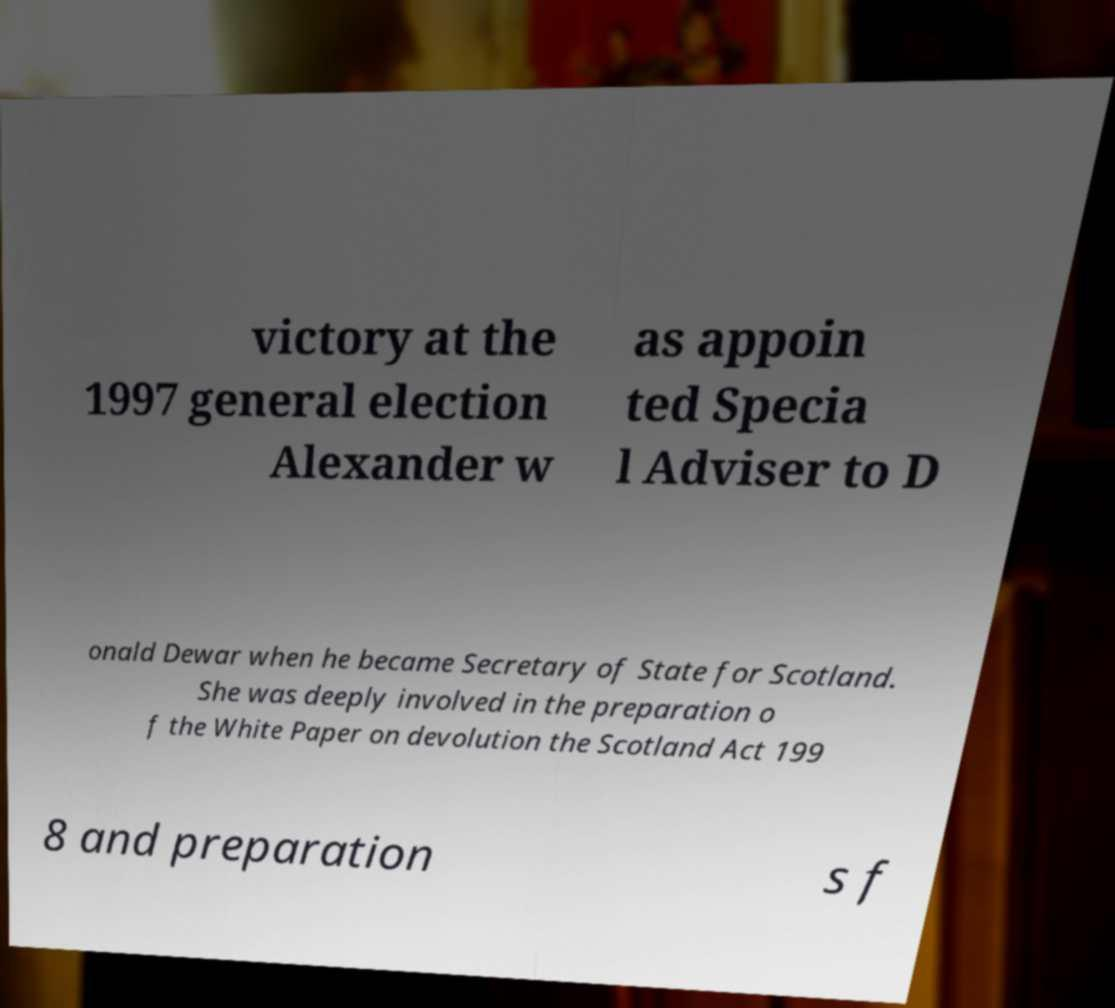I need the written content from this picture converted into text. Can you do that? victory at the 1997 general election Alexander w as appoin ted Specia l Adviser to D onald Dewar when he became Secretary of State for Scotland. She was deeply involved in the preparation o f the White Paper on devolution the Scotland Act 199 8 and preparation s f 